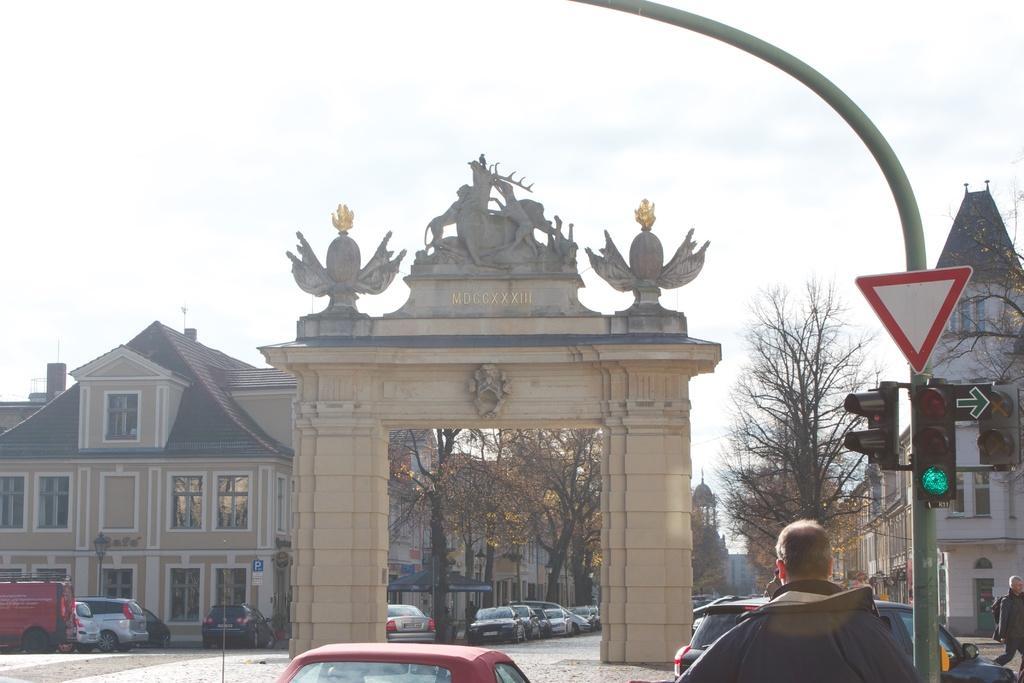Could you give a brief overview of what you see in this image? In this picture I can observe an entrance in the middle of the picture. In the bottom of the picture I can observe some cars. On the right side there is a pole to which traffic signals are fixed. In the background there are buildings, trees and sky. 